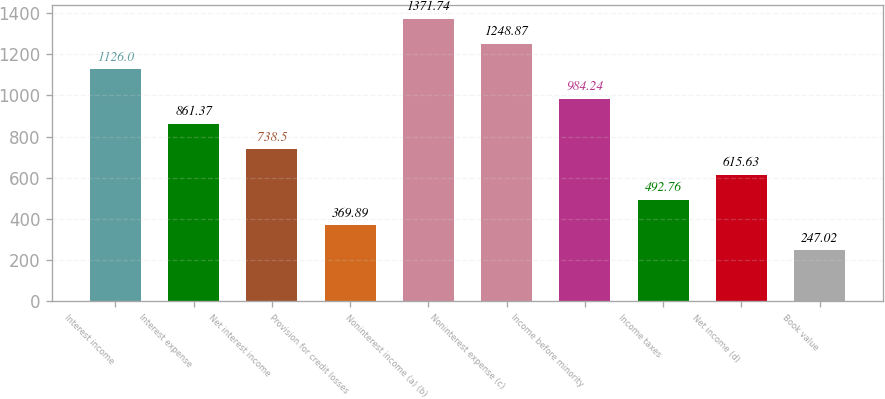<chart> <loc_0><loc_0><loc_500><loc_500><bar_chart><fcel>Interest income<fcel>Interest expense<fcel>Net interest income<fcel>Provision for credit losses<fcel>Noninterest income (a) (b)<fcel>Noninterest expense (c)<fcel>Income before minority<fcel>Income taxes<fcel>Net income (d)<fcel>Book value<nl><fcel>1126<fcel>861.37<fcel>738.5<fcel>369.89<fcel>1371.74<fcel>1248.87<fcel>984.24<fcel>492.76<fcel>615.63<fcel>247.02<nl></chart> 